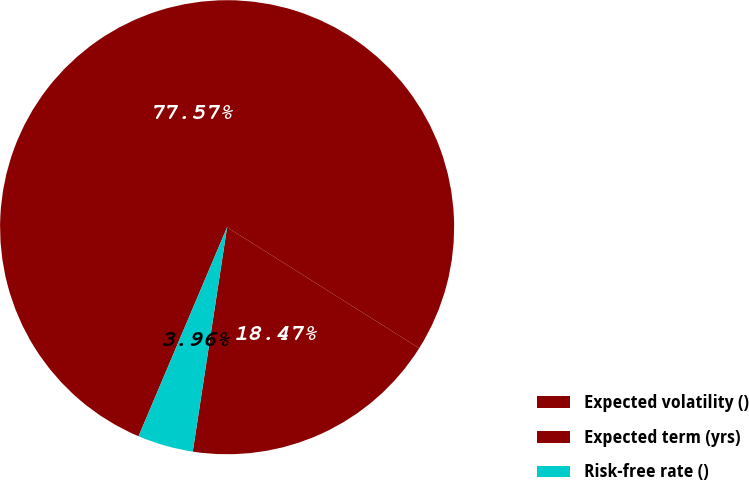Convert chart. <chart><loc_0><loc_0><loc_500><loc_500><pie_chart><fcel>Expected volatility ()<fcel>Expected term (yrs)<fcel>Risk-free rate ()<nl><fcel>77.57%<fcel>18.47%<fcel>3.96%<nl></chart> 